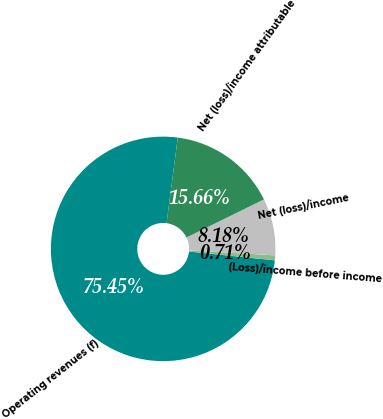<chart> <loc_0><loc_0><loc_500><loc_500><pie_chart><fcel>Operating revenues (f)<fcel>(Loss)/income before income<fcel>Net (loss)/income<fcel>Net (loss)/income attributable<nl><fcel>75.45%<fcel>0.71%<fcel>8.18%<fcel>15.66%<nl></chart> 